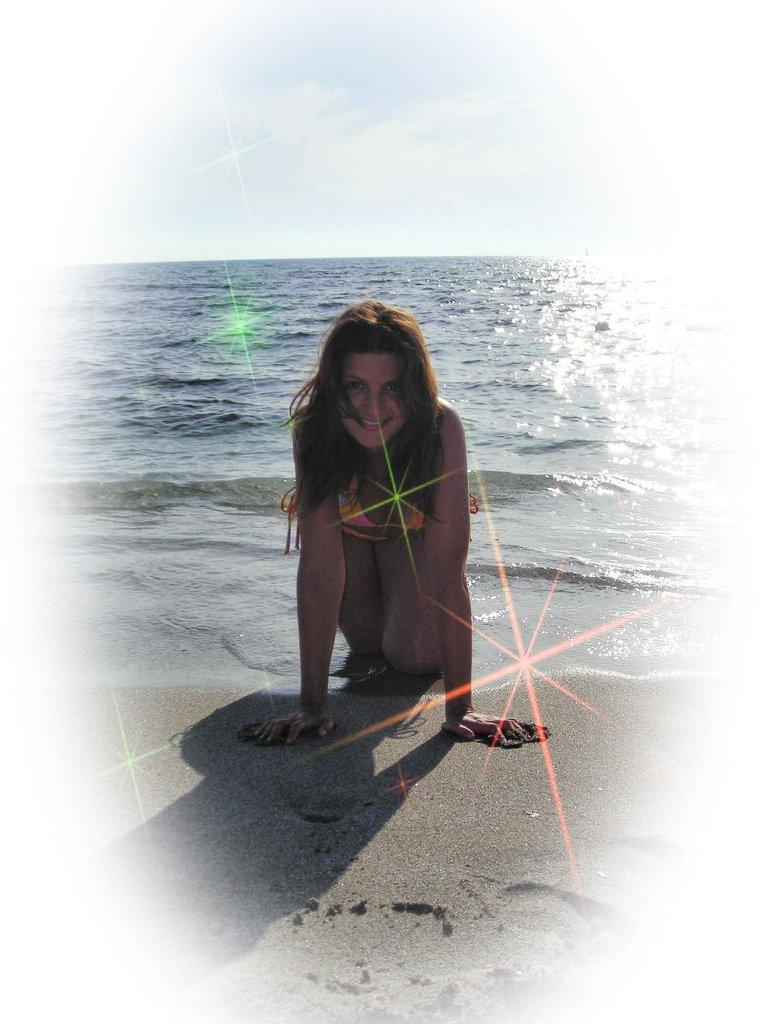Who is present in the image? There is a woman in the image. What is the woman's expression in the image? The woman is smiling in the image. What can be seen in the background of the image? Water and the sky are visible in the background of the image. What type of science experiment is the woman conducting in the image? There is no science experiment present in the image; it features a woman smiling with water and the sky visible in the background. 